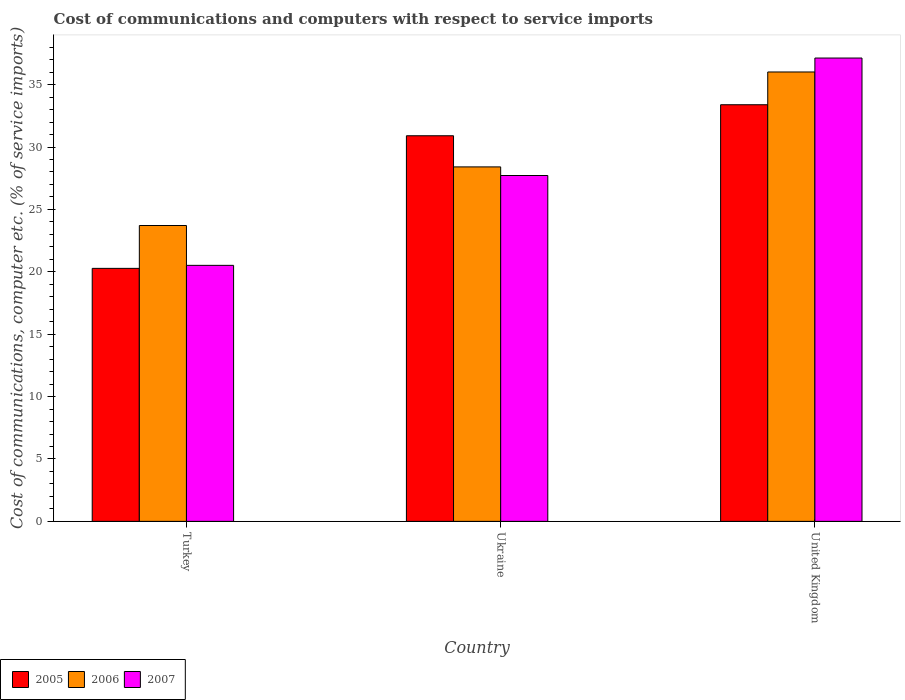How many groups of bars are there?
Provide a short and direct response. 3. How many bars are there on the 1st tick from the left?
Provide a short and direct response. 3. What is the label of the 2nd group of bars from the left?
Offer a terse response. Ukraine. In how many cases, is the number of bars for a given country not equal to the number of legend labels?
Keep it short and to the point. 0. What is the cost of communications and computers in 2006 in Ukraine?
Your answer should be very brief. 28.41. Across all countries, what is the maximum cost of communications and computers in 2006?
Your answer should be very brief. 36.02. Across all countries, what is the minimum cost of communications and computers in 2006?
Your answer should be compact. 23.71. In which country was the cost of communications and computers in 2007 maximum?
Keep it short and to the point. United Kingdom. In which country was the cost of communications and computers in 2007 minimum?
Your response must be concise. Turkey. What is the total cost of communications and computers in 2006 in the graph?
Give a very brief answer. 88.14. What is the difference between the cost of communications and computers in 2006 in Turkey and that in Ukraine?
Give a very brief answer. -4.7. What is the difference between the cost of communications and computers in 2005 in United Kingdom and the cost of communications and computers in 2006 in Ukraine?
Ensure brevity in your answer.  4.98. What is the average cost of communications and computers in 2006 per country?
Offer a very short reply. 29.38. What is the difference between the cost of communications and computers of/in 2005 and cost of communications and computers of/in 2006 in United Kingdom?
Your answer should be very brief. -2.63. What is the ratio of the cost of communications and computers in 2005 in Ukraine to that in United Kingdom?
Your answer should be very brief. 0.93. What is the difference between the highest and the second highest cost of communications and computers in 2005?
Your answer should be compact. 13.11. What is the difference between the highest and the lowest cost of communications and computers in 2005?
Make the answer very short. 13.11. What does the 1st bar from the left in Turkey represents?
Provide a succinct answer. 2005. Is it the case that in every country, the sum of the cost of communications and computers in 2005 and cost of communications and computers in 2006 is greater than the cost of communications and computers in 2007?
Your response must be concise. Yes. How many bars are there?
Your response must be concise. 9. Are all the bars in the graph horizontal?
Provide a short and direct response. No. Where does the legend appear in the graph?
Provide a short and direct response. Bottom left. How many legend labels are there?
Keep it short and to the point. 3. What is the title of the graph?
Provide a succinct answer. Cost of communications and computers with respect to service imports. What is the label or title of the X-axis?
Provide a succinct answer. Country. What is the label or title of the Y-axis?
Make the answer very short. Cost of communications, computer etc. (% of service imports). What is the Cost of communications, computer etc. (% of service imports) in 2005 in Turkey?
Provide a short and direct response. 20.28. What is the Cost of communications, computer etc. (% of service imports) in 2006 in Turkey?
Make the answer very short. 23.71. What is the Cost of communications, computer etc. (% of service imports) in 2007 in Turkey?
Your response must be concise. 20.52. What is the Cost of communications, computer etc. (% of service imports) in 2005 in Ukraine?
Give a very brief answer. 30.9. What is the Cost of communications, computer etc. (% of service imports) in 2006 in Ukraine?
Your answer should be compact. 28.41. What is the Cost of communications, computer etc. (% of service imports) of 2007 in Ukraine?
Provide a short and direct response. 27.72. What is the Cost of communications, computer etc. (% of service imports) in 2005 in United Kingdom?
Keep it short and to the point. 33.39. What is the Cost of communications, computer etc. (% of service imports) of 2006 in United Kingdom?
Provide a succinct answer. 36.02. What is the Cost of communications, computer etc. (% of service imports) in 2007 in United Kingdom?
Your response must be concise. 37.13. Across all countries, what is the maximum Cost of communications, computer etc. (% of service imports) of 2005?
Your answer should be compact. 33.39. Across all countries, what is the maximum Cost of communications, computer etc. (% of service imports) in 2006?
Offer a very short reply. 36.02. Across all countries, what is the maximum Cost of communications, computer etc. (% of service imports) of 2007?
Provide a short and direct response. 37.13. Across all countries, what is the minimum Cost of communications, computer etc. (% of service imports) of 2005?
Give a very brief answer. 20.28. Across all countries, what is the minimum Cost of communications, computer etc. (% of service imports) of 2006?
Keep it short and to the point. 23.71. Across all countries, what is the minimum Cost of communications, computer etc. (% of service imports) in 2007?
Offer a terse response. 20.52. What is the total Cost of communications, computer etc. (% of service imports) of 2005 in the graph?
Your answer should be very brief. 84.57. What is the total Cost of communications, computer etc. (% of service imports) of 2006 in the graph?
Your answer should be very brief. 88.14. What is the total Cost of communications, computer etc. (% of service imports) of 2007 in the graph?
Your answer should be very brief. 85.37. What is the difference between the Cost of communications, computer etc. (% of service imports) of 2005 in Turkey and that in Ukraine?
Offer a very short reply. -10.63. What is the difference between the Cost of communications, computer etc. (% of service imports) in 2006 in Turkey and that in Ukraine?
Provide a succinct answer. -4.7. What is the difference between the Cost of communications, computer etc. (% of service imports) in 2007 in Turkey and that in Ukraine?
Your response must be concise. -7.2. What is the difference between the Cost of communications, computer etc. (% of service imports) in 2005 in Turkey and that in United Kingdom?
Offer a terse response. -13.11. What is the difference between the Cost of communications, computer etc. (% of service imports) of 2006 in Turkey and that in United Kingdom?
Keep it short and to the point. -12.3. What is the difference between the Cost of communications, computer etc. (% of service imports) in 2007 in Turkey and that in United Kingdom?
Your answer should be compact. -16.62. What is the difference between the Cost of communications, computer etc. (% of service imports) in 2005 in Ukraine and that in United Kingdom?
Your answer should be very brief. -2.49. What is the difference between the Cost of communications, computer etc. (% of service imports) in 2006 in Ukraine and that in United Kingdom?
Keep it short and to the point. -7.61. What is the difference between the Cost of communications, computer etc. (% of service imports) in 2007 in Ukraine and that in United Kingdom?
Provide a succinct answer. -9.41. What is the difference between the Cost of communications, computer etc. (% of service imports) in 2005 in Turkey and the Cost of communications, computer etc. (% of service imports) in 2006 in Ukraine?
Keep it short and to the point. -8.13. What is the difference between the Cost of communications, computer etc. (% of service imports) in 2005 in Turkey and the Cost of communications, computer etc. (% of service imports) in 2007 in Ukraine?
Your answer should be compact. -7.44. What is the difference between the Cost of communications, computer etc. (% of service imports) of 2006 in Turkey and the Cost of communications, computer etc. (% of service imports) of 2007 in Ukraine?
Offer a very short reply. -4.01. What is the difference between the Cost of communications, computer etc. (% of service imports) in 2005 in Turkey and the Cost of communications, computer etc. (% of service imports) in 2006 in United Kingdom?
Ensure brevity in your answer.  -15.74. What is the difference between the Cost of communications, computer etc. (% of service imports) in 2005 in Turkey and the Cost of communications, computer etc. (% of service imports) in 2007 in United Kingdom?
Offer a very short reply. -16.86. What is the difference between the Cost of communications, computer etc. (% of service imports) of 2006 in Turkey and the Cost of communications, computer etc. (% of service imports) of 2007 in United Kingdom?
Give a very brief answer. -13.42. What is the difference between the Cost of communications, computer etc. (% of service imports) of 2005 in Ukraine and the Cost of communications, computer etc. (% of service imports) of 2006 in United Kingdom?
Your answer should be very brief. -5.11. What is the difference between the Cost of communications, computer etc. (% of service imports) of 2005 in Ukraine and the Cost of communications, computer etc. (% of service imports) of 2007 in United Kingdom?
Your answer should be compact. -6.23. What is the difference between the Cost of communications, computer etc. (% of service imports) of 2006 in Ukraine and the Cost of communications, computer etc. (% of service imports) of 2007 in United Kingdom?
Give a very brief answer. -8.72. What is the average Cost of communications, computer etc. (% of service imports) in 2005 per country?
Make the answer very short. 28.19. What is the average Cost of communications, computer etc. (% of service imports) of 2006 per country?
Provide a short and direct response. 29.38. What is the average Cost of communications, computer etc. (% of service imports) of 2007 per country?
Your response must be concise. 28.46. What is the difference between the Cost of communications, computer etc. (% of service imports) in 2005 and Cost of communications, computer etc. (% of service imports) in 2006 in Turkey?
Your answer should be very brief. -3.44. What is the difference between the Cost of communications, computer etc. (% of service imports) in 2005 and Cost of communications, computer etc. (% of service imports) in 2007 in Turkey?
Make the answer very short. -0.24. What is the difference between the Cost of communications, computer etc. (% of service imports) in 2006 and Cost of communications, computer etc. (% of service imports) in 2007 in Turkey?
Your response must be concise. 3.19. What is the difference between the Cost of communications, computer etc. (% of service imports) of 2005 and Cost of communications, computer etc. (% of service imports) of 2006 in Ukraine?
Keep it short and to the point. 2.5. What is the difference between the Cost of communications, computer etc. (% of service imports) in 2005 and Cost of communications, computer etc. (% of service imports) in 2007 in Ukraine?
Offer a very short reply. 3.19. What is the difference between the Cost of communications, computer etc. (% of service imports) in 2006 and Cost of communications, computer etc. (% of service imports) in 2007 in Ukraine?
Keep it short and to the point. 0.69. What is the difference between the Cost of communications, computer etc. (% of service imports) in 2005 and Cost of communications, computer etc. (% of service imports) in 2006 in United Kingdom?
Give a very brief answer. -2.63. What is the difference between the Cost of communications, computer etc. (% of service imports) of 2005 and Cost of communications, computer etc. (% of service imports) of 2007 in United Kingdom?
Keep it short and to the point. -3.74. What is the difference between the Cost of communications, computer etc. (% of service imports) of 2006 and Cost of communications, computer etc. (% of service imports) of 2007 in United Kingdom?
Offer a very short reply. -1.12. What is the ratio of the Cost of communications, computer etc. (% of service imports) of 2005 in Turkey to that in Ukraine?
Provide a succinct answer. 0.66. What is the ratio of the Cost of communications, computer etc. (% of service imports) of 2006 in Turkey to that in Ukraine?
Your answer should be very brief. 0.83. What is the ratio of the Cost of communications, computer etc. (% of service imports) of 2007 in Turkey to that in Ukraine?
Give a very brief answer. 0.74. What is the ratio of the Cost of communications, computer etc. (% of service imports) in 2005 in Turkey to that in United Kingdom?
Provide a succinct answer. 0.61. What is the ratio of the Cost of communications, computer etc. (% of service imports) of 2006 in Turkey to that in United Kingdom?
Provide a short and direct response. 0.66. What is the ratio of the Cost of communications, computer etc. (% of service imports) in 2007 in Turkey to that in United Kingdom?
Ensure brevity in your answer.  0.55. What is the ratio of the Cost of communications, computer etc. (% of service imports) in 2005 in Ukraine to that in United Kingdom?
Your answer should be compact. 0.93. What is the ratio of the Cost of communications, computer etc. (% of service imports) in 2006 in Ukraine to that in United Kingdom?
Give a very brief answer. 0.79. What is the ratio of the Cost of communications, computer etc. (% of service imports) in 2007 in Ukraine to that in United Kingdom?
Ensure brevity in your answer.  0.75. What is the difference between the highest and the second highest Cost of communications, computer etc. (% of service imports) in 2005?
Offer a very short reply. 2.49. What is the difference between the highest and the second highest Cost of communications, computer etc. (% of service imports) in 2006?
Offer a terse response. 7.61. What is the difference between the highest and the second highest Cost of communications, computer etc. (% of service imports) of 2007?
Keep it short and to the point. 9.41. What is the difference between the highest and the lowest Cost of communications, computer etc. (% of service imports) in 2005?
Offer a very short reply. 13.11. What is the difference between the highest and the lowest Cost of communications, computer etc. (% of service imports) in 2006?
Your response must be concise. 12.3. What is the difference between the highest and the lowest Cost of communications, computer etc. (% of service imports) in 2007?
Offer a terse response. 16.62. 